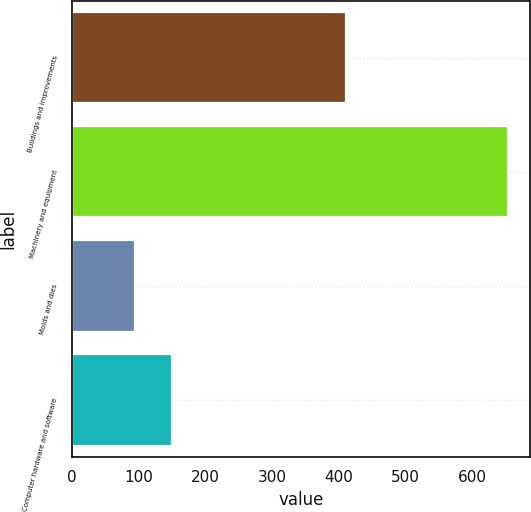<chart> <loc_0><loc_0><loc_500><loc_500><bar_chart><fcel>Buildings and improvements<fcel>Machinery and equipment<fcel>Molds and dies<fcel>Computer hardware and software<nl><fcel>410.6<fcel>654.1<fcel>94.8<fcel>150.73<nl></chart> 